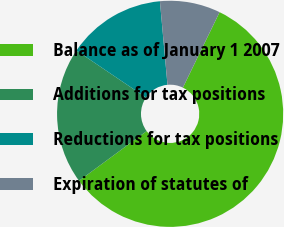Convert chart to OTSL. <chart><loc_0><loc_0><loc_500><loc_500><pie_chart><fcel>Balance as of January 1 2007<fcel>Additions for tax positions<fcel>Reductions for tax positions<fcel>Expiration of statutes of<nl><fcel>57.7%<fcel>19.55%<fcel>14.1%<fcel>8.65%<nl></chart> 